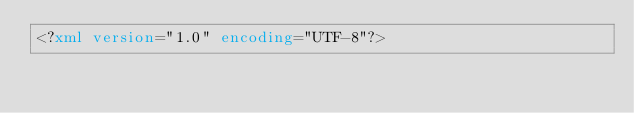Convert code to text. <code><loc_0><loc_0><loc_500><loc_500><_XML_><?xml version="1.0" encoding="UTF-8"?></code> 